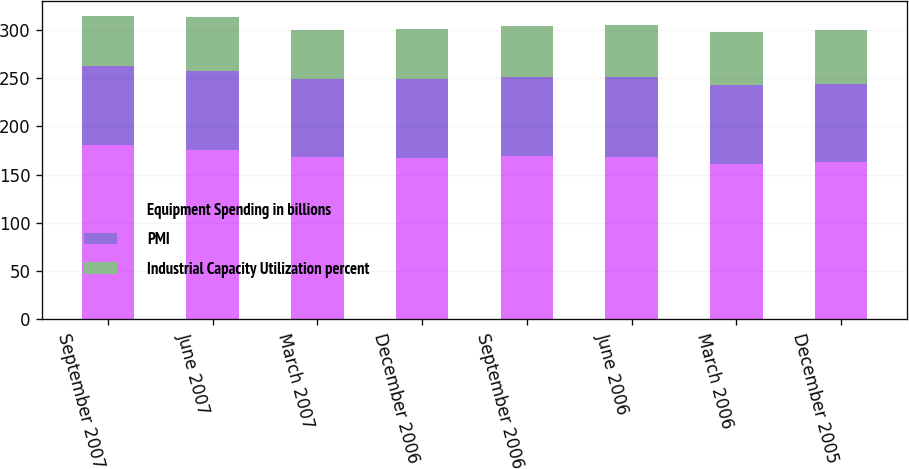<chart> <loc_0><loc_0><loc_500><loc_500><stacked_bar_chart><ecel><fcel>September 2007<fcel>June 2007<fcel>March 2007<fcel>December 2006<fcel>September 2006<fcel>June 2006<fcel>March 2006<fcel>December 2005<nl><fcel>Equipment Spending in billions<fcel>180.4<fcel>176<fcel>168.1<fcel>167.5<fcel>169.2<fcel>168.5<fcel>161.5<fcel>162.8<nl><fcel>PMI<fcel>82.1<fcel>81.8<fcel>81.4<fcel>81.6<fcel>82<fcel>82.3<fcel>81.4<fcel>81.3<nl><fcel>Industrial Capacity Utilization percent<fcel>52<fcel>56<fcel>50.9<fcel>51.4<fcel>52.7<fcel>54<fcel>55.3<fcel>55.5<nl></chart> 